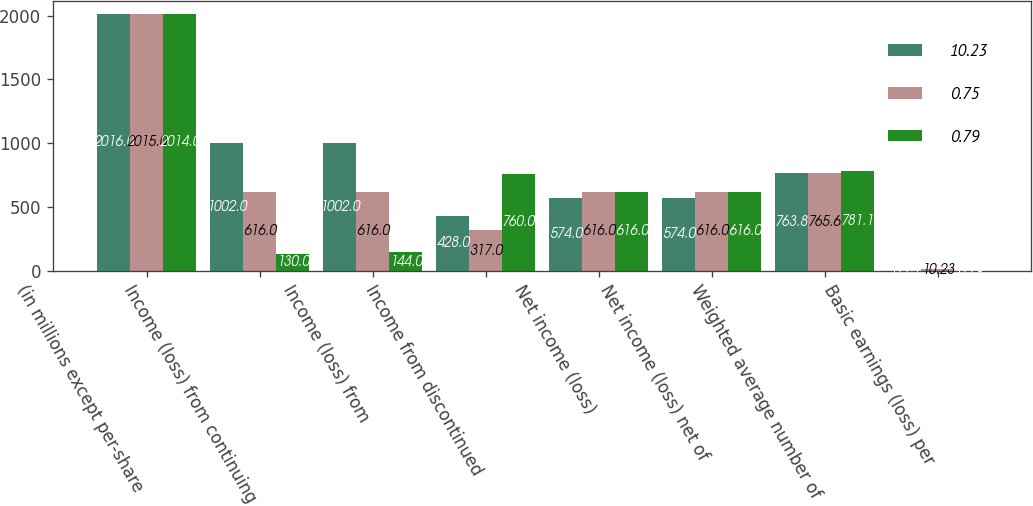Convert chart to OTSL. <chart><loc_0><loc_0><loc_500><loc_500><stacked_bar_chart><ecel><fcel>(in millions except per-share<fcel>Income (loss) from continuing<fcel>Income (loss) from<fcel>Income from discontinued<fcel>Net income (loss)<fcel>Net income (loss) net of<fcel>Weighted average number of<fcel>Basic earnings (loss) per<nl><fcel>10.23<fcel>2016<fcel>1002<fcel>1002<fcel>428<fcel>574<fcel>574<fcel>763.8<fcel>0.75<nl><fcel>0.75<fcel>2015<fcel>616<fcel>616<fcel>317<fcel>616<fcel>616<fcel>765.6<fcel>10.23<nl><fcel>0.79<fcel>2014<fcel>130<fcel>144<fcel>760<fcel>616<fcel>616<fcel>781.1<fcel>0.79<nl></chart> 